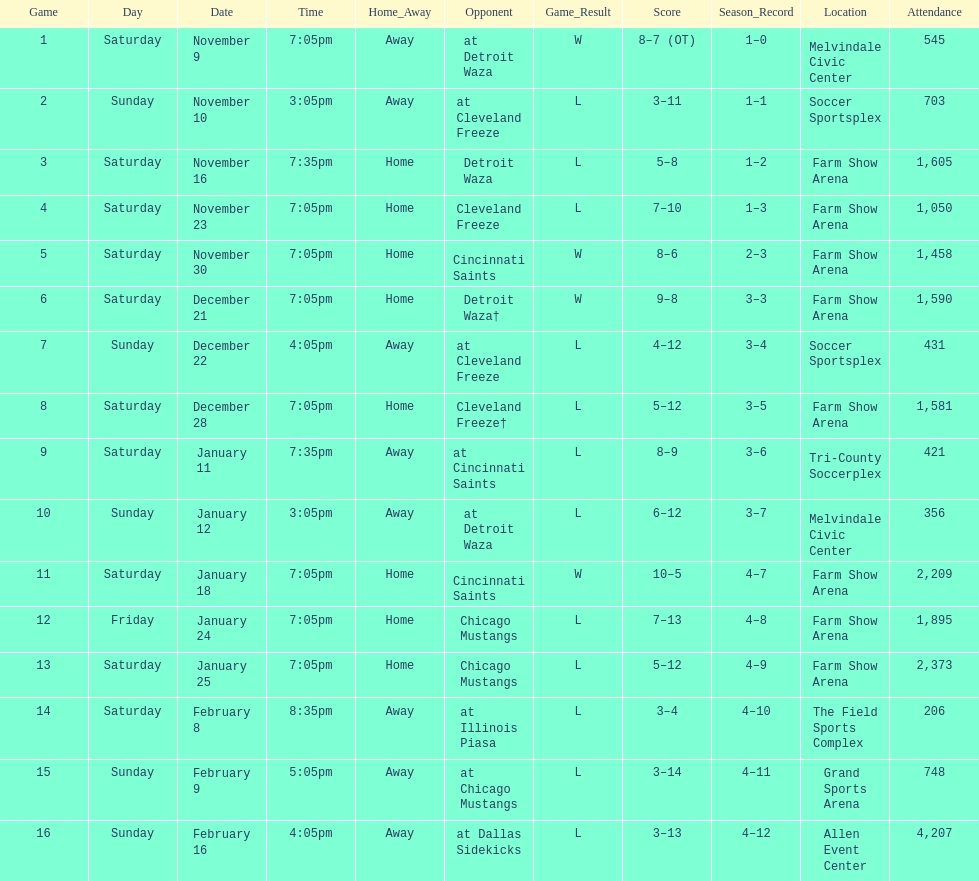Which opponent is listed first in the table? Detroit Waza. 